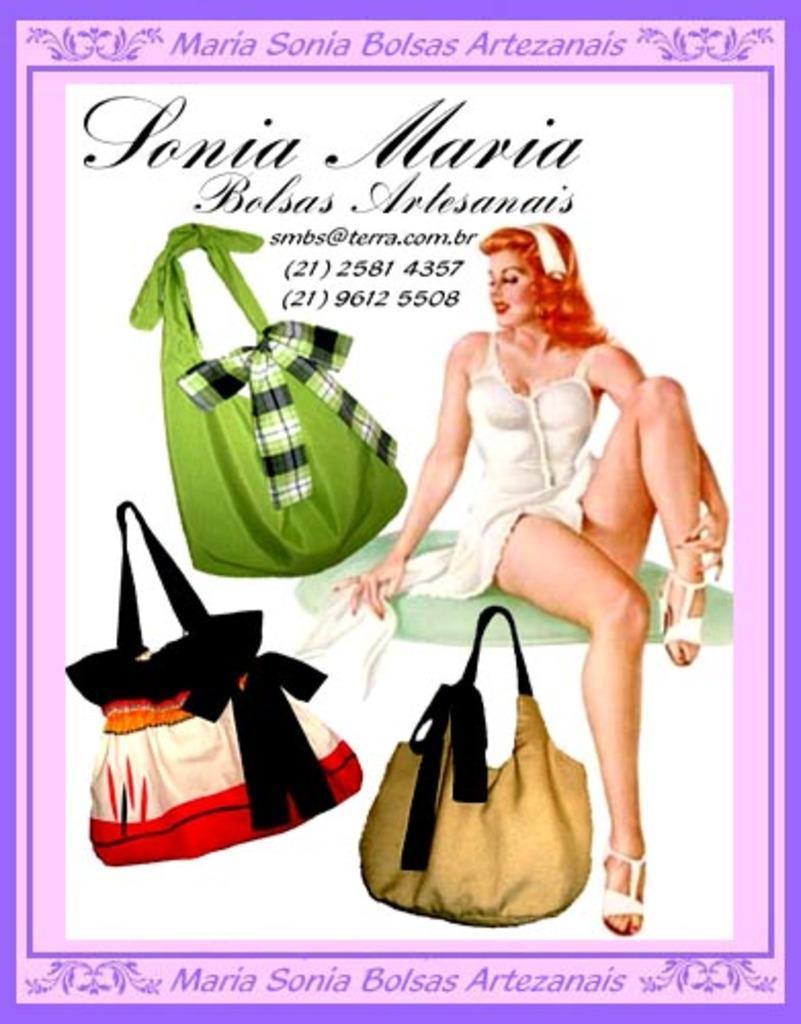Can you describe this image briefly? There is a poster having an image of a woman who is in white color dress and is smiling and sitting on a surface, there are black color texts, there are different colors bags and violet color borders. And the background of this poster is white in color. 